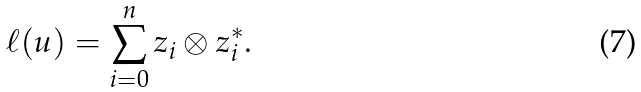<formula> <loc_0><loc_0><loc_500><loc_500>\ell ( u ) = \sum _ { i = 0 } ^ { n } z _ { i } \otimes z _ { i } ^ { * } .</formula> 